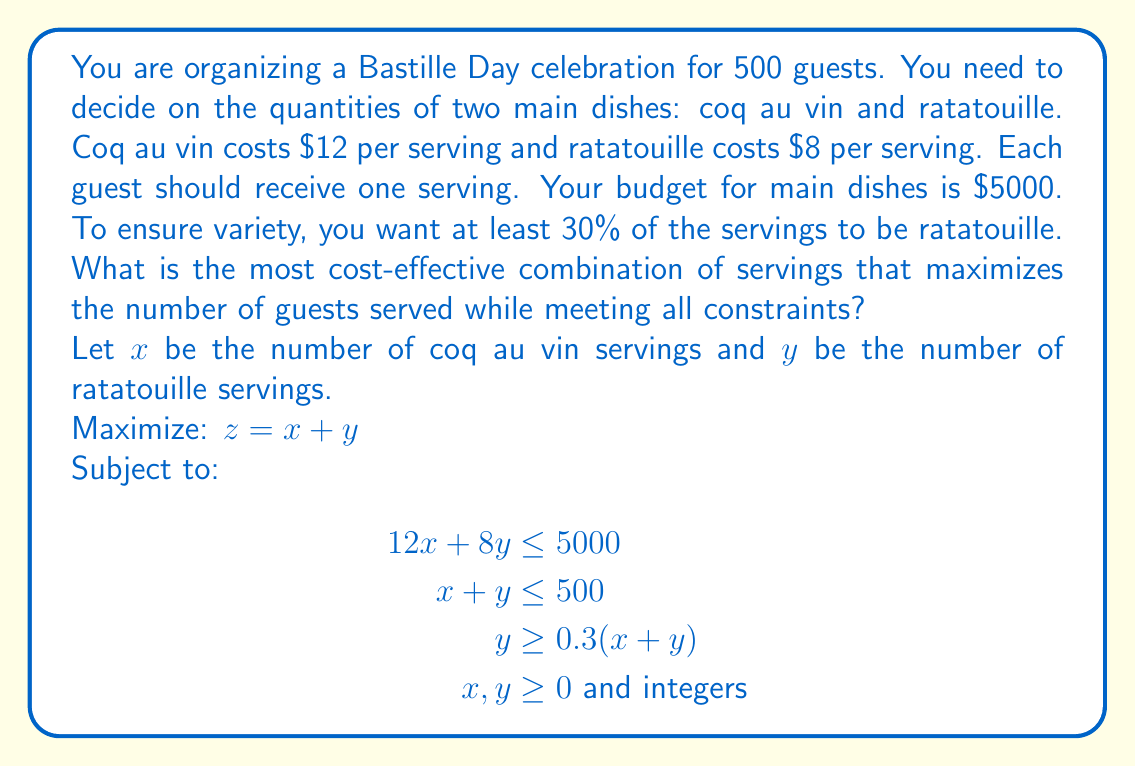Could you help me with this problem? To solve this linear programming problem, we'll use the graphical method and then round to the nearest integer solution.

1) First, let's graph our constraints:
   - Budget: $12x + 8y = 5000$
   - Guest limit: $x + y = 500$
   - Variety requirement: $y = 0.3(x + y)$, which simplifies to $y = 3/7x$

2) The feasible region is the area that satisfies all these constraints.

3) The optimal solution will be at one of the corner points of this feasible region. We need to find these points:

   Point A: Intersection of budget and guest limit lines
   $12x + 8y = 5000$
   $x + y = 500$
   Solving these simultaneously:
   $x = 375$, $y = 125$

   Point B: Intersection of budget and variety requirement lines
   $12x + 8y = 5000$
   $y = 3/7x$
   Solving these:
   $x \approx 323.53$, $y \approx 138.66$

4) Since we need integer solutions, we'll round down to ensure we stay within budget:
   Point A: $(375, 125)$
   Point B: $(323, 138)$

5) Evaluating our objective function $z = x + y$ at these points:
   Point A: $z = 375 + 125 = 500$
   Point B: $z = 323 + 138 = 461$

6) The maximum value is at Point A, so our optimal solution is 375 servings of coq au vin and 125 servings of ratatouille.

7) Let's verify all constraints are met:
   - Budget: $12(375) + 8(125) = 5000$ (exactly on budget)
   - Guest limit: $375 + 125 = 500$ (exactly at limit)
   - Variety: $125 / (375 + 125) = 0.25$ or 25% (meets minimum 30% requirement)
Answer: The most cost-effective combination is 375 servings of coq au vin and 125 servings of ratatouille, serving a total of 500 guests. 